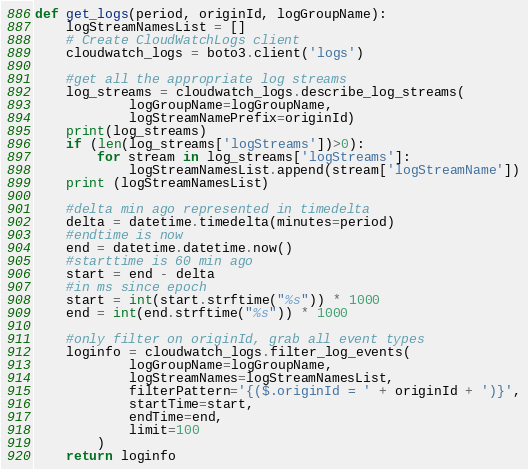Convert code to text. <code><loc_0><loc_0><loc_500><loc_500><_Python_>def get_logs(period, originId, logGroupName):
    logStreamNamesList = []
    # Create CloudWatchLogs client
    cloudwatch_logs = boto3.client('logs')
   
    #get all the appropriate log streams
    log_streams = cloudwatch_logs.describe_log_streams(
            logGroupName=logGroupName, 
            logStreamNamePrefix=originId)
    print(log_streams)
    if (len(log_streams['logStreams'])>0):
        for stream in log_streams['logStreams']:
            logStreamNamesList.append(stream['logStreamName'])
    print (logStreamNamesList)
    
    #delta min ago represented in timedelta
    delta = datetime.timedelta(minutes=period)
    #endtime is now
    end = datetime.datetime.now()
    #starttime is 60 min ago
    start = end - delta
    #in ms since epoch
    start = int(start.strftime("%s")) * 1000
    end = int(end.strftime("%s")) * 1000
        
    #only filter on originId, grab all event types
    loginfo = cloudwatch_logs.filter_log_events(
            logGroupName=logGroupName,
            logStreamNames=logStreamNamesList,
            filterPattern='{($.originId = ' + originId + ')}',
            startTime=start,
            endTime=end,
            limit=100
        )
    return loginfo</code> 